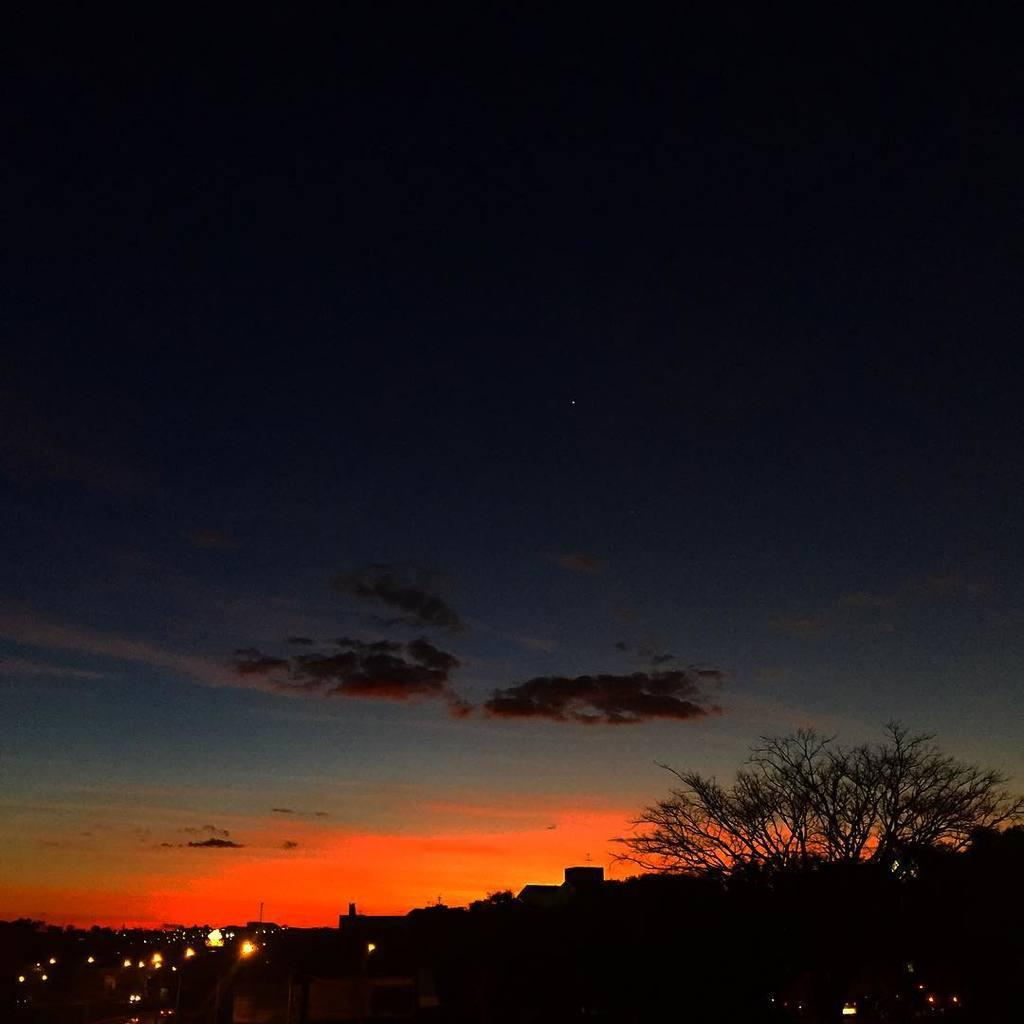What can be seen in the sky in the image? There are clouds in the sky in the image. What type of structures are visible at the bottom of the image? There are buildings with lights at the bottom of the image. What type of plant is present in the image? There is a tree with branches in the image. What type of shoes can be seen on the branches of the tree in the image? There are no shoes present on the branches of the tree in the image. What is the frame made of in the image? There is no frame present in the image. 